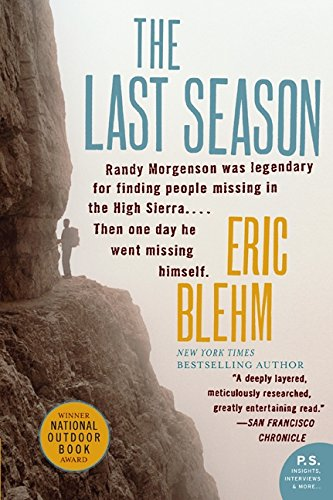Is this a financial book? No, 'The Last Season' is not a financial book. It is an exploration of personal stories and adventures in the high Sierra. 